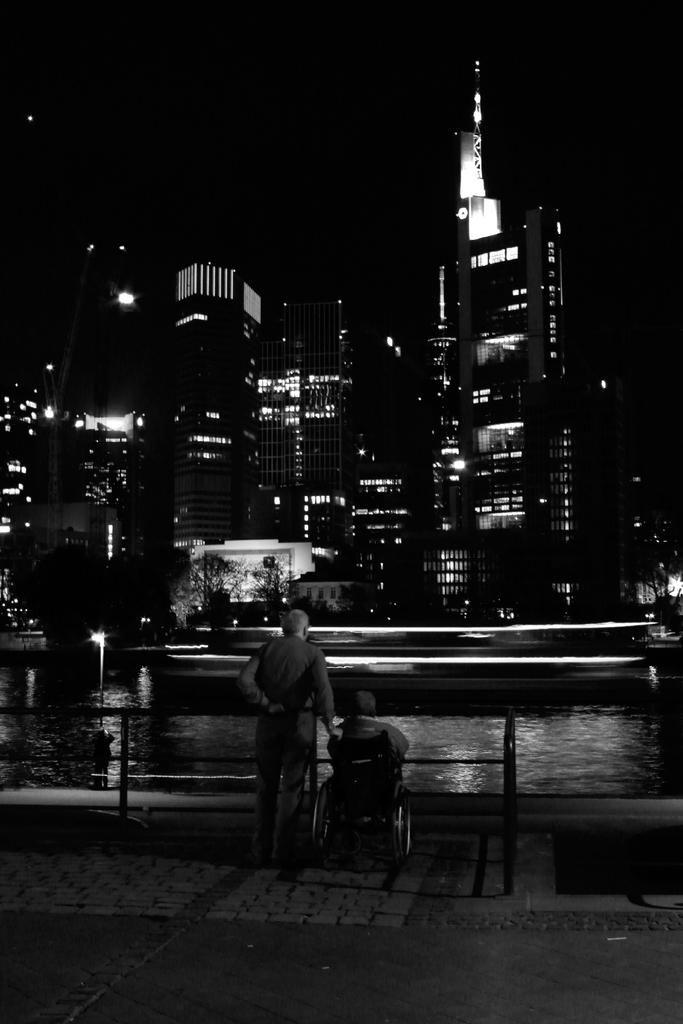What type of structures can be seen in the image? There are many buildings in the image. What natural feature is present in front of the buildings? There is a water lake in front of the buildings. Can you describe the activity of the people in the image? Two people are watching something in the image. Reasoning: Let's think step by step by step in order to produce the conversation. We start by identifying the main subjects in the image, which are the buildings and the water lake. Then, we mention the presence of the two people and their activity, which is watching something. Each question is designed to elicit a specific detail about the image that is known from the provided facts. Absurd Question/Answer: What type of silk is being used by the carpenter in the image? There is no carpenter or silk present in the image. What type of ship can be seen sailing on the water lake in the image? There is no ship visible in the image; it only shows buildings, a water lake, and two people watching something. What type of silk is being used by the carpenter in the image? There is no carpenter or silk present in the image. What type of ship can be seen sailing on the water lake in the image? There is no ship visible in the image; it only shows buildings, a water lake, and two people watching something. 